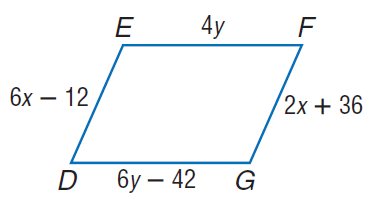Answer the mathemtical geometry problem and directly provide the correct option letter.
Question: Find x so that the quadrilateral is a parallelogram.
Choices: A: 12 B: 24 C: 60 D: 72 A 